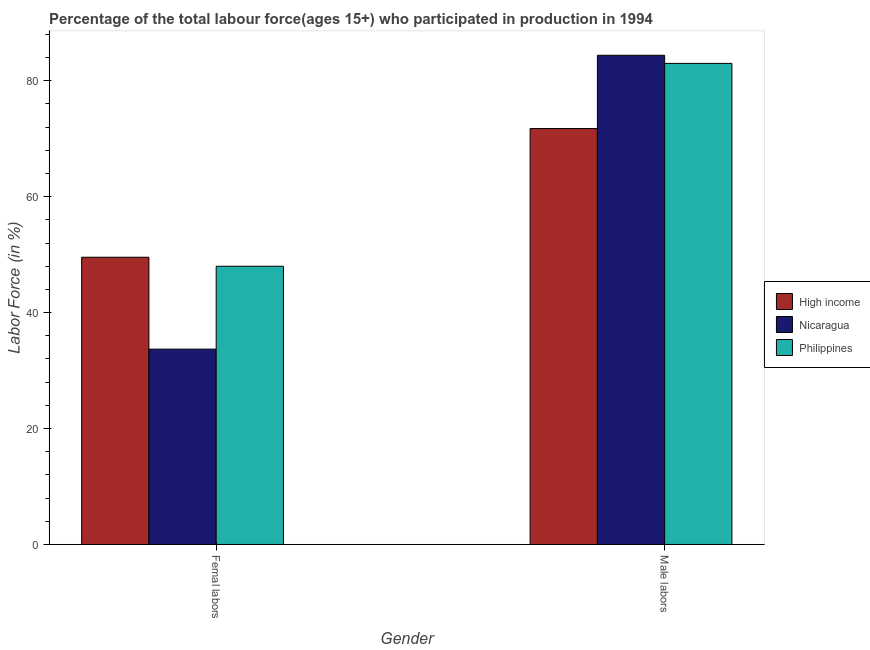Are the number of bars per tick equal to the number of legend labels?
Offer a very short reply. Yes. Are the number of bars on each tick of the X-axis equal?
Give a very brief answer. Yes. How many bars are there on the 1st tick from the left?
Ensure brevity in your answer.  3. What is the label of the 1st group of bars from the left?
Give a very brief answer. Femal labors. What is the percentage of male labour force in Philippines?
Provide a succinct answer. 83. Across all countries, what is the maximum percentage of male labour force?
Provide a short and direct response. 84.4. Across all countries, what is the minimum percentage of male labour force?
Give a very brief answer. 71.76. In which country was the percentage of female labor force maximum?
Your response must be concise. High income. In which country was the percentage of female labor force minimum?
Your answer should be very brief. Nicaragua. What is the total percentage of male labour force in the graph?
Offer a very short reply. 239.16. What is the difference between the percentage of female labor force in Nicaragua and that in High income?
Your answer should be compact. -15.86. What is the difference between the percentage of male labour force in Nicaragua and the percentage of female labor force in High income?
Offer a terse response. 34.84. What is the average percentage of male labour force per country?
Your answer should be very brief. 79.72. What is the difference between the percentage of female labor force and percentage of male labour force in Nicaragua?
Make the answer very short. -50.7. What is the ratio of the percentage of female labor force in High income to that in Philippines?
Offer a very short reply. 1.03. Is the percentage of female labor force in Philippines less than that in Nicaragua?
Offer a terse response. No. In how many countries, is the percentage of female labor force greater than the average percentage of female labor force taken over all countries?
Keep it short and to the point. 2. What does the 1st bar from the left in Male labors represents?
Your answer should be very brief. High income. What does the 2nd bar from the right in Male labors represents?
Make the answer very short. Nicaragua. How many bars are there?
Your response must be concise. 6. Are all the bars in the graph horizontal?
Keep it short and to the point. No. How many countries are there in the graph?
Make the answer very short. 3. What is the difference between two consecutive major ticks on the Y-axis?
Provide a short and direct response. 20. Are the values on the major ticks of Y-axis written in scientific E-notation?
Provide a short and direct response. No. Where does the legend appear in the graph?
Your answer should be compact. Center right. What is the title of the graph?
Offer a terse response. Percentage of the total labour force(ages 15+) who participated in production in 1994. What is the label or title of the X-axis?
Offer a very short reply. Gender. What is the label or title of the Y-axis?
Provide a short and direct response. Labor Force (in %). What is the Labor Force (in %) of High income in Femal labors?
Your answer should be very brief. 49.56. What is the Labor Force (in %) of Nicaragua in Femal labors?
Make the answer very short. 33.7. What is the Labor Force (in %) of High income in Male labors?
Your answer should be very brief. 71.76. What is the Labor Force (in %) in Nicaragua in Male labors?
Provide a short and direct response. 84.4. Across all Gender, what is the maximum Labor Force (in %) in High income?
Offer a terse response. 71.76. Across all Gender, what is the maximum Labor Force (in %) of Nicaragua?
Your response must be concise. 84.4. Across all Gender, what is the maximum Labor Force (in %) of Philippines?
Offer a terse response. 83. Across all Gender, what is the minimum Labor Force (in %) of High income?
Offer a very short reply. 49.56. Across all Gender, what is the minimum Labor Force (in %) in Nicaragua?
Provide a short and direct response. 33.7. What is the total Labor Force (in %) of High income in the graph?
Your response must be concise. 121.32. What is the total Labor Force (in %) in Nicaragua in the graph?
Your answer should be very brief. 118.1. What is the total Labor Force (in %) of Philippines in the graph?
Make the answer very short. 131. What is the difference between the Labor Force (in %) of High income in Femal labors and that in Male labors?
Ensure brevity in your answer.  -22.2. What is the difference between the Labor Force (in %) in Nicaragua in Femal labors and that in Male labors?
Give a very brief answer. -50.7. What is the difference between the Labor Force (in %) of Philippines in Femal labors and that in Male labors?
Provide a succinct answer. -35. What is the difference between the Labor Force (in %) of High income in Femal labors and the Labor Force (in %) of Nicaragua in Male labors?
Your response must be concise. -34.84. What is the difference between the Labor Force (in %) of High income in Femal labors and the Labor Force (in %) of Philippines in Male labors?
Provide a succinct answer. -33.44. What is the difference between the Labor Force (in %) in Nicaragua in Femal labors and the Labor Force (in %) in Philippines in Male labors?
Keep it short and to the point. -49.3. What is the average Labor Force (in %) in High income per Gender?
Provide a short and direct response. 60.66. What is the average Labor Force (in %) in Nicaragua per Gender?
Your answer should be very brief. 59.05. What is the average Labor Force (in %) in Philippines per Gender?
Make the answer very short. 65.5. What is the difference between the Labor Force (in %) of High income and Labor Force (in %) of Nicaragua in Femal labors?
Your answer should be compact. 15.86. What is the difference between the Labor Force (in %) in High income and Labor Force (in %) in Philippines in Femal labors?
Give a very brief answer. 1.56. What is the difference between the Labor Force (in %) in Nicaragua and Labor Force (in %) in Philippines in Femal labors?
Provide a short and direct response. -14.3. What is the difference between the Labor Force (in %) in High income and Labor Force (in %) in Nicaragua in Male labors?
Provide a short and direct response. -12.64. What is the difference between the Labor Force (in %) in High income and Labor Force (in %) in Philippines in Male labors?
Offer a terse response. -11.24. What is the ratio of the Labor Force (in %) in High income in Femal labors to that in Male labors?
Your response must be concise. 0.69. What is the ratio of the Labor Force (in %) in Nicaragua in Femal labors to that in Male labors?
Provide a short and direct response. 0.4. What is the ratio of the Labor Force (in %) in Philippines in Femal labors to that in Male labors?
Your answer should be compact. 0.58. What is the difference between the highest and the second highest Labor Force (in %) of High income?
Ensure brevity in your answer.  22.2. What is the difference between the highest and the second highest Labor Force (in %) in Nicaragua?
Offer a very short reply. 50.7. What is the difference between the highest and the lowest Labor Force (in %) in High income?
Keep it short and to the point. 22.2. What is the difference between the highest and the lowest Labor Force (in %) in Nicaragua?
Give a very brief answer. 50.7. What is the difference between the highest and the lowest Labor Force (in %) in Philippines?
Your response must be concise. 35. 